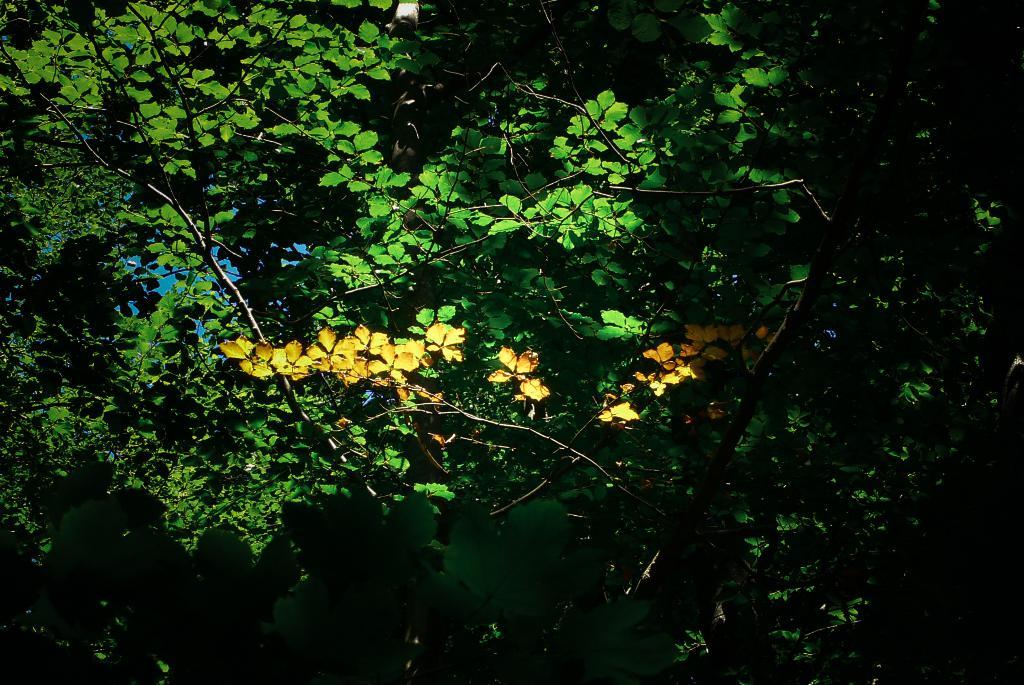What type of vegetation can be seen in the image? There are leaves in the image. What colors are the leaves? The leaves are green and yellow in color. What else is visible in the image besides the leaves? The sky is visible in the image. How many geese are flying in the sky in the image? There are no geese visible in the image; only leaves and the sky are present. 